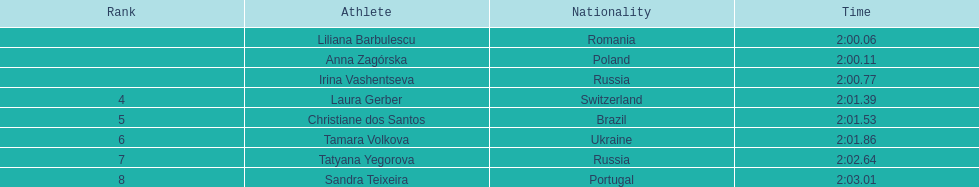During the 2003 summer universiade, who were the women athletes in the 800 meters race? , Liliana Barbulescu, Anna Zagórska, Irina Vashentseva, Laura Gerber, Christiane dos Santos, Tamara Volkova, Tatyana Yegorova, Sandra Teixeira. What time did anna zagorska finish in? 2:00.11. 